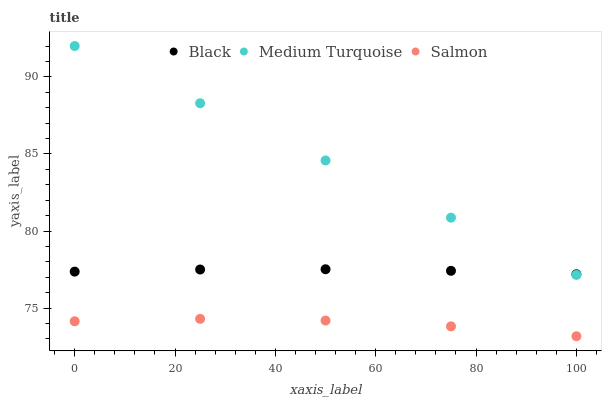Does Salmon have the minimum area under the curve?
Answer yes or no. Yes. Does Medium Turquoise have the maximum area under the curve?
Answer yes or no. Yes. Does Black have the minimum area under the curve?
Answer yes or no. No. Does Black have the maximum area under the curve?
Answer yes or no. No. Is Medium Turquoise the smoothest?
Answer yes or no. Yes. Is Salmon the roughest?
Answer yes or no. Yes. Is Black the smoothest?
Answer yes or no. No. Is Black the roughest?
Answer yes or no. No. Does Salmon have the lowest value?
Answer yes or no. Yes. Does Medium Turquoise have the lowest value?
Answer yes or no. No. Does Medium Turquoise have the highest value?
Answer yes or no. Yes. Does Black have the highest value?
Answer yes or no. No. Is Salmon less than Medium Turquoise?
Answer yes or no. Yes. Is Black greater than Salmon?
Answer yes or no. Yes. Does Medium Turquoise intersect Black?
Answer yes or no. Yes. Is Medium Turquoise less than Black?
Answer yes or no. No. Is Medium Turquoise greater than Black?
Answer yes or no. No. Does Salmon intersect Medium Turquoise?
Answer yes or no. No. 